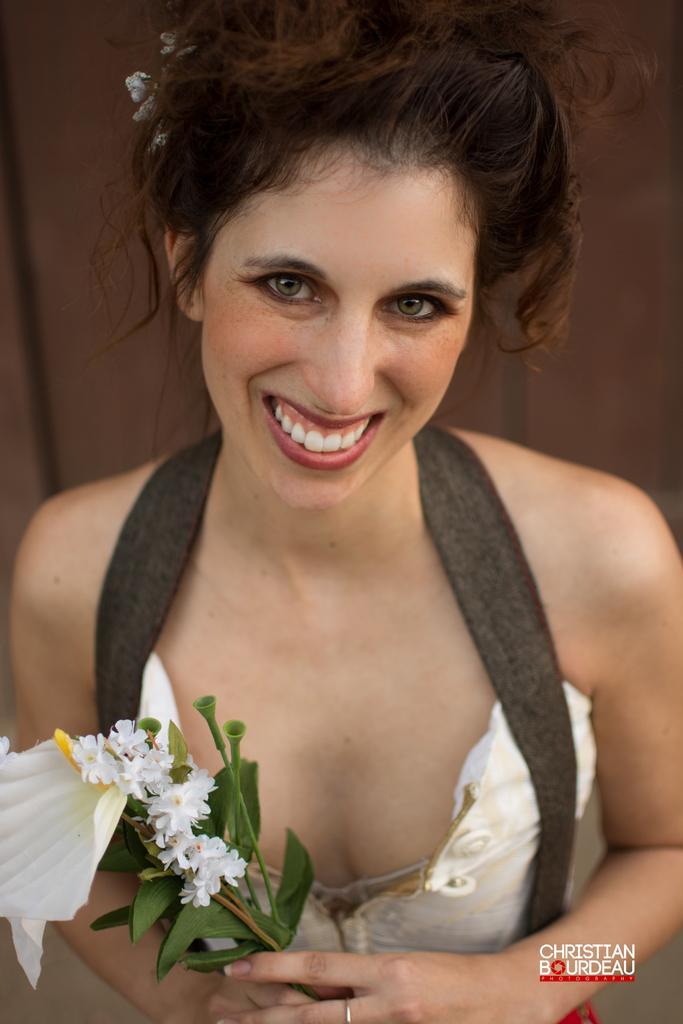How would you summarize this image in a sentence or two? In this image we can see a woman holding a flower bouquet with her hand and she is smiling. At the bottom of the image we can see a watermark. 